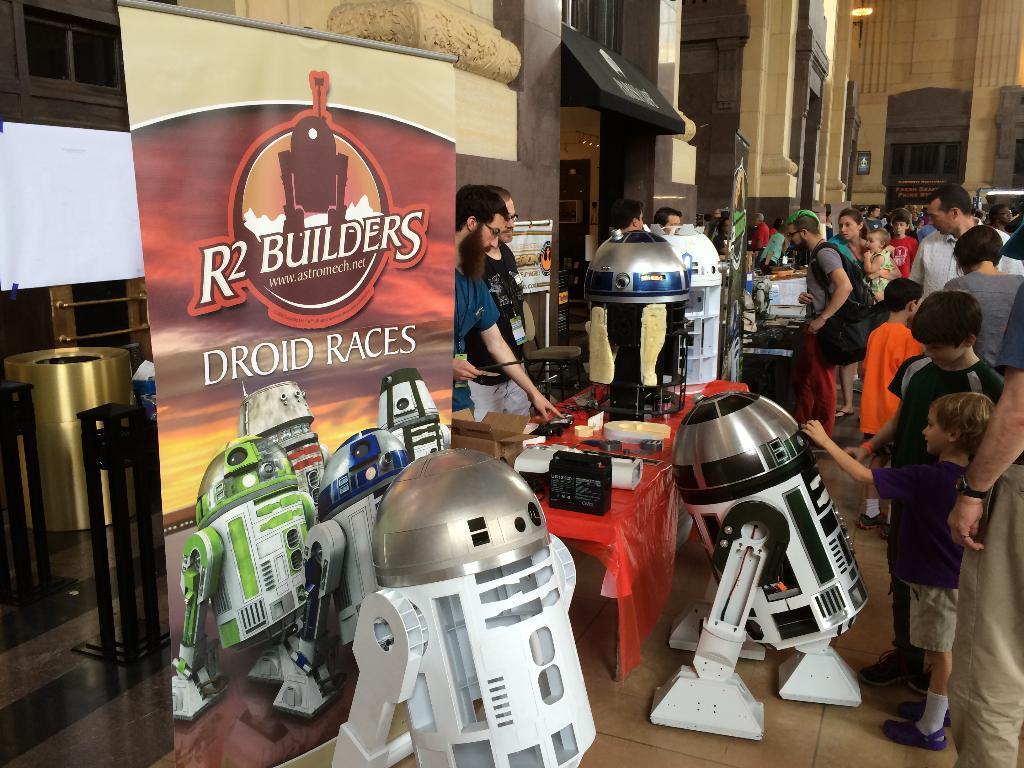In one or two sentences, can you explain what this image depicts? In this image I can see few robots which are white and silver in color on the ground and I can see number of people standing on the ground and a banner which is brown and cream in color. In the background I can see few buildings which are brown in color. 